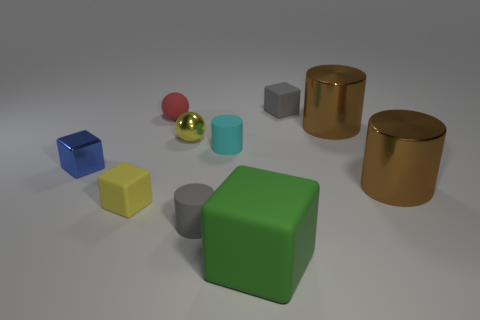Subtract all red spheres. How many brown cylinders are left? 2 Subtract all small gray matte cylinders. How many cylinders are left? 3 Subtract 1 cubes. How many cubes are left? 3 Subtract all gray cylinders. How many cylinders are left? 3 Subtract all blue cylinders. Subtract all green spheres. How many cylinders are left? 4 Subtract 0 green balls. How many objects are left? 10 Subtract all cylinders. How many objects are left? 6 Subtract all large green things. Subtract all spheres. How many objects are left? 7 Add 2 small yellow matte things. How many small yellow matte things are left? 3 Add 7 large red shiny cubes. How many large red shiny cubes exist? 7 